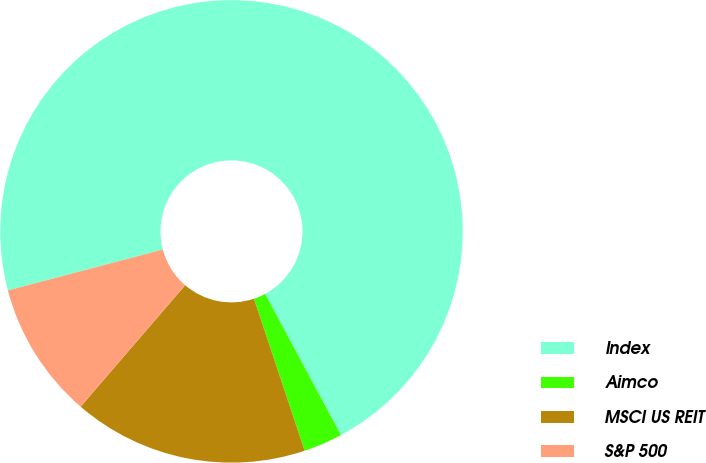<chart> <loc_0><loc_0><loc_500><loc_500><pie_chart><fcel>Index<fcel>Aimco<fcel>MSCI US REIT<fcel>S&P 500<nl><fcel>71.26%<fcel>2.73%<fcel>16.43%<fcel>9.58%<nl></chart> 